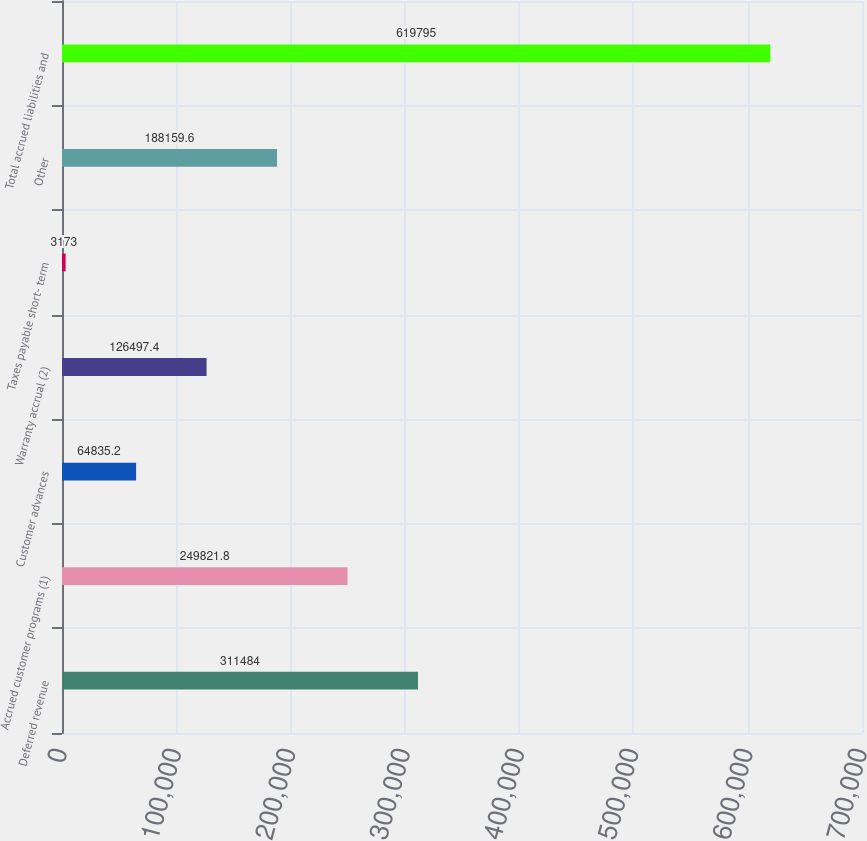Convert chart. <chart><loc_0><loc_0><loc_500><loc_500><bar_chart><fcel>Deferred revenue<fcel>Accrued customer programs (1)<fcel>Customer advances<fcel>Warranty accrual (2)<fcel>Taxes payable short- term<fcel>Other<fcel>Total accrued liabilities and<nl><fcel>311484<fcel>249822<fcel>64835.2<fcel>126497<fcel>3173<fcel>188160<fcel>619795<nl></chart> 